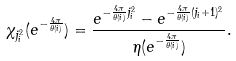Convert formula to latex. <formula><loc_0><loc_0><loc_500><loc_500>\chi _ { j _ { i } ^ { 2 } } ( e ^ { - \frac { 4 \pi } { \theta ( i ) } } ) = \frac { e ^ { - \frac { 4 \pi } { \theta ( i ) } j _ { i } ^ { 2 } } - e ^ { - \frac { 4 \pi } { \theta ( i ) } ( j _ { i } + 1 ) ^ { 2 } } } { \eta ( e ^ { - \frac { 4 \pi } { \theta ( i ) } } ) } .</formula> 